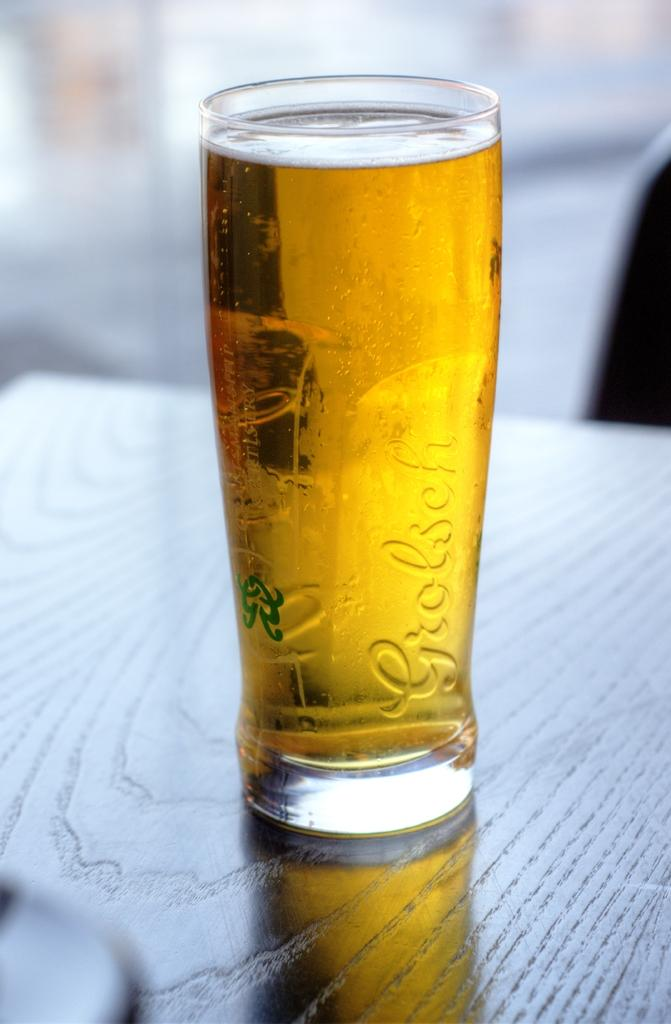<image>
Give a short and clear explanation of the subsequent image. a full glass of Grolsch beer on a wooden table 